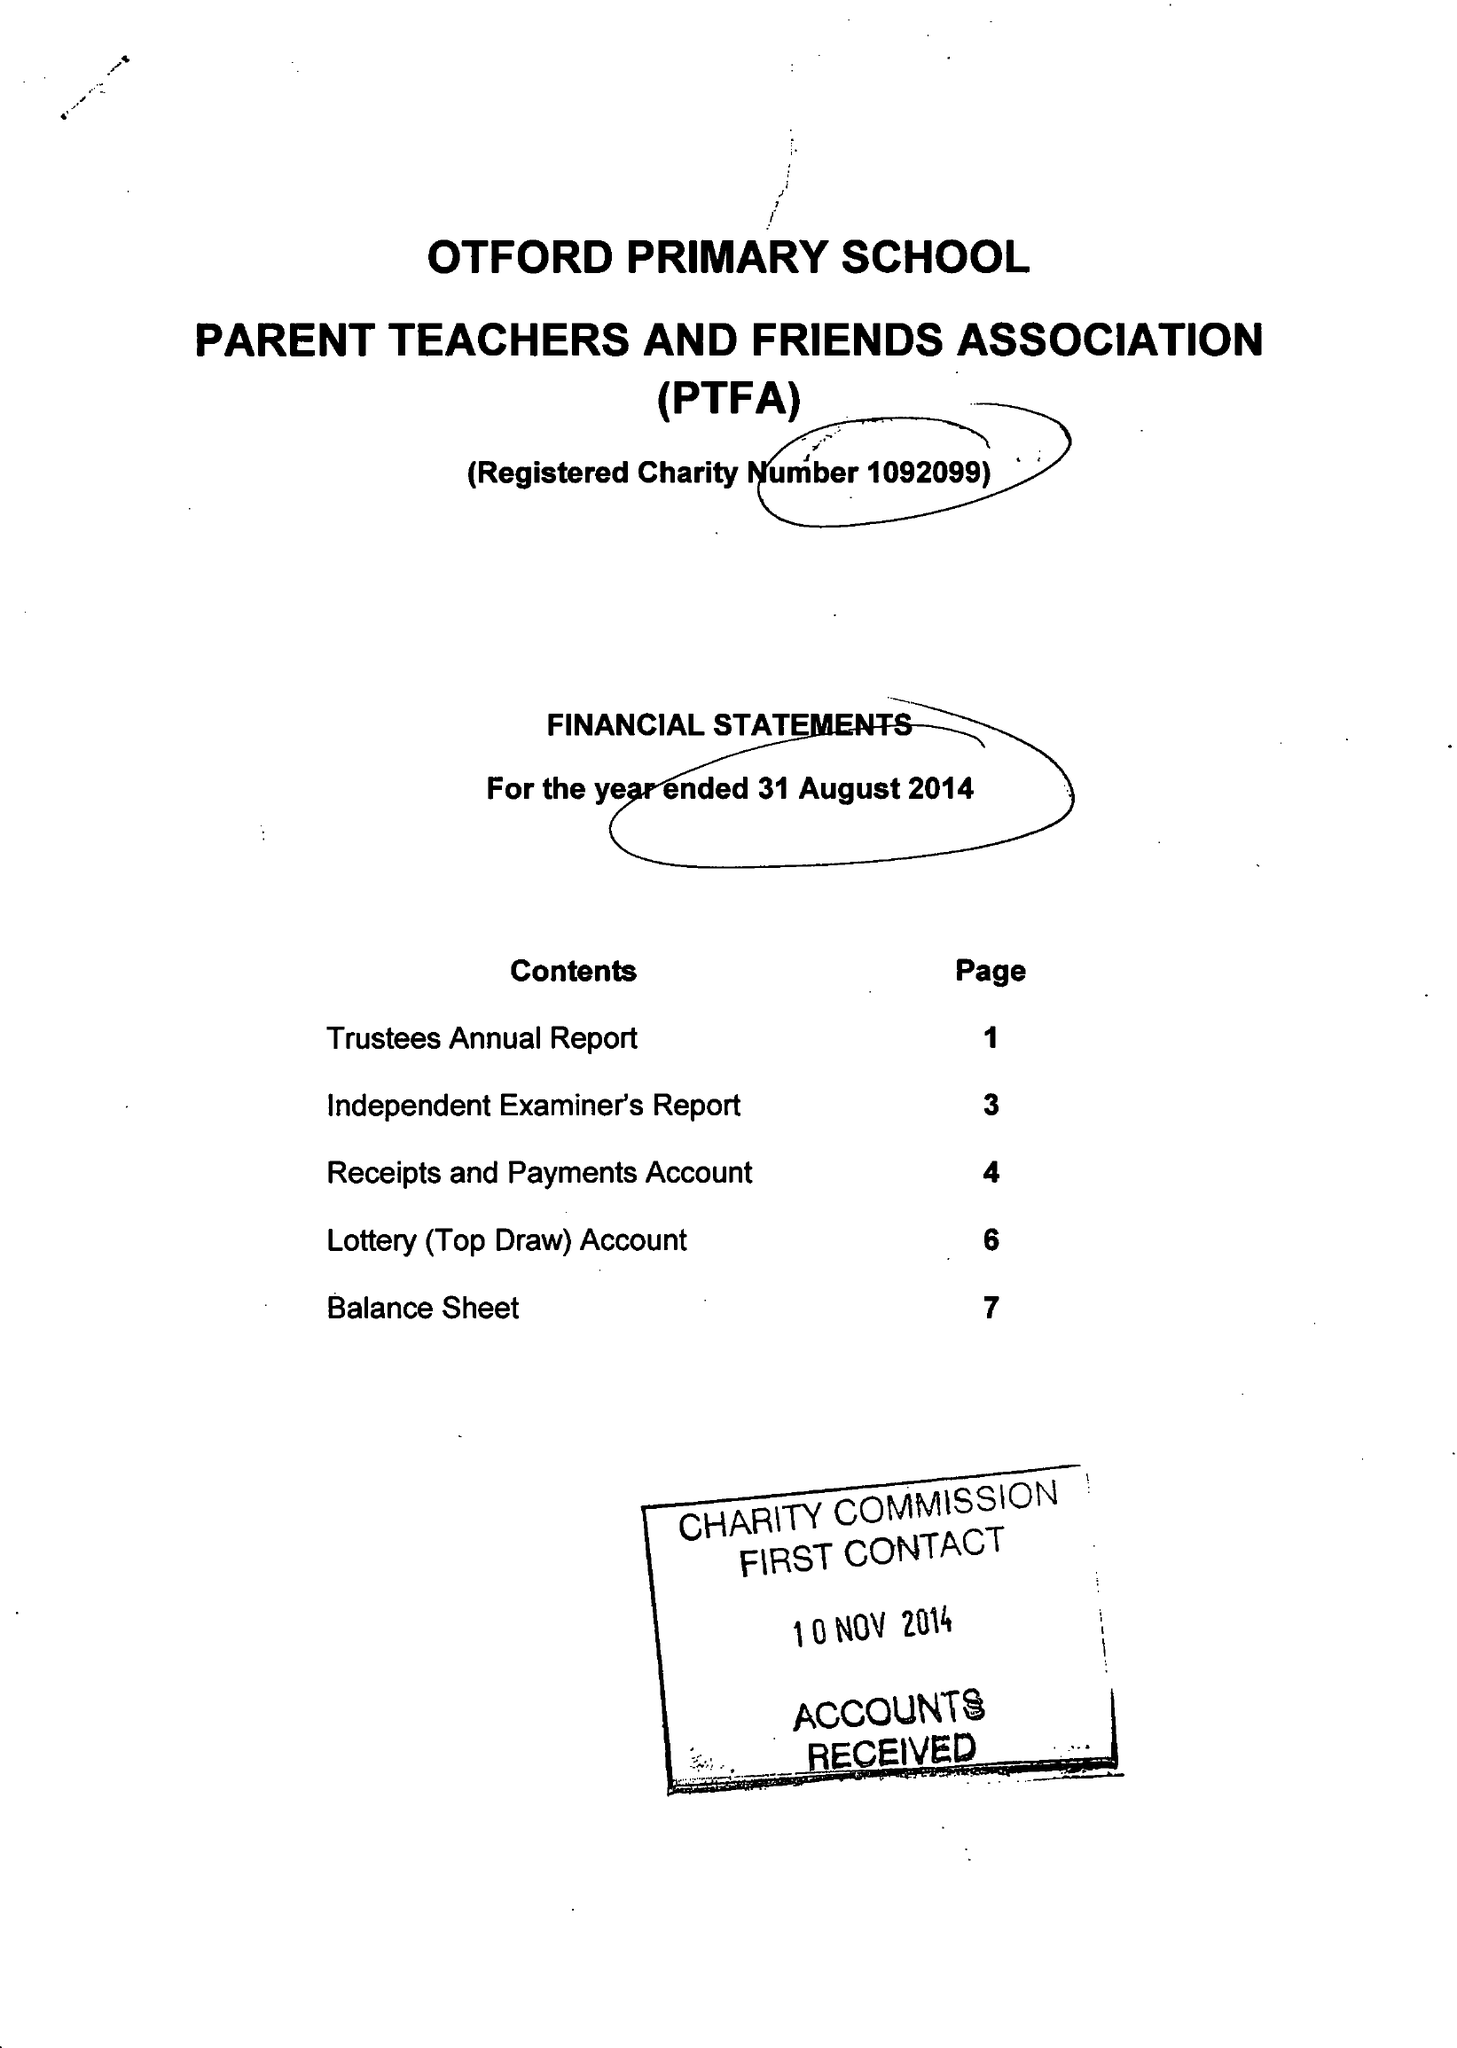What is the value for the charity_name?
Answer the question using a single word or phrase. Otford Primary School Ptfa 